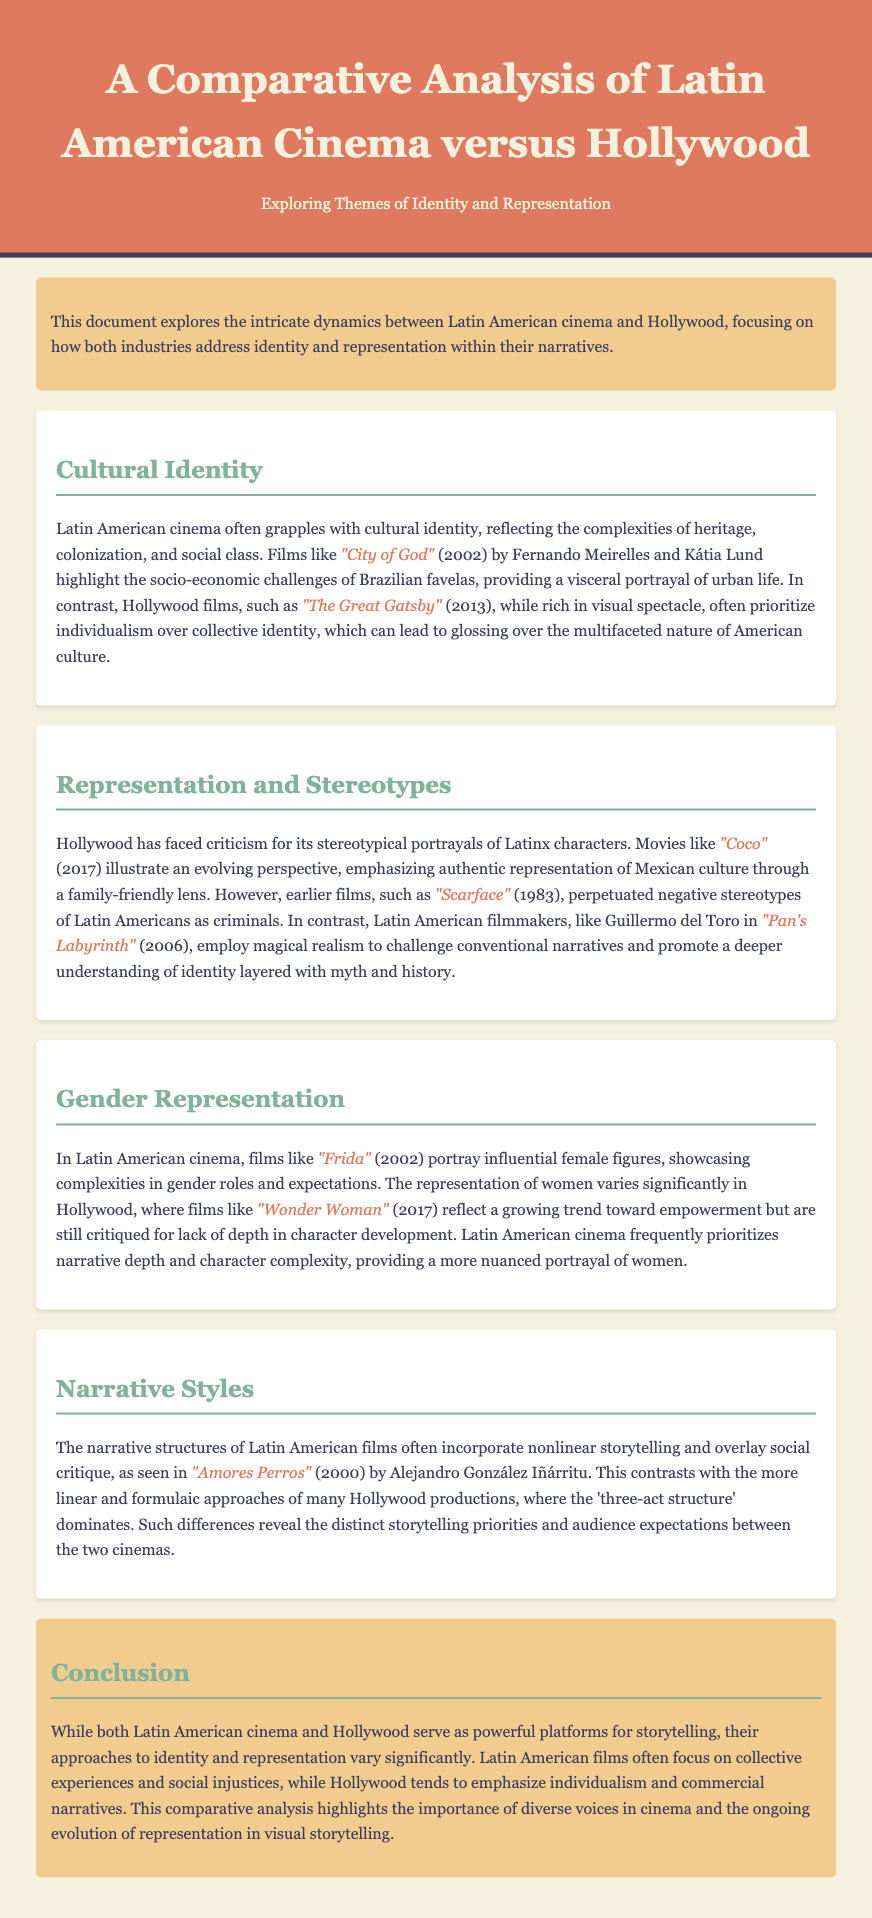What two films highlight socio-economic challenges in Brazilian favelas? The document mentions "City of God" by Fernando Meirelles and Kátia Lund to illustrate socio-economic challenges.
Answer: City of God Which film is cited as an example of Hollywood's stereotypical portrayal of Latinx characters? The document references "Scarface" as a film that perpetuated negative stereotypes of Latin Americans.
Answer: Scarface What narrative technique is noted as common in Latin American cinema? The text describes nonlinear storytelling as a common narrative structure in Latin American films.
Answer: Nonlinear storytelling Which film by Guillermo del Toro challenges conventional narratives? The document states that "Pan's Labyrinth" employs magical realism to promote a deeper understanding of identity.
Answer: Pan's Labyrinth What is a key theme of Latin American cinema mentioned in the document? The document identifies collective experiences and social injustices as key themes frequently explored in Latin American films.
Answer: Collective experiences Which film represents a growing trend toward women's empowerment in Hollywood? The document points to "Wonder Woman" as reflecting a trend in the portrayal of empowered female figures.
Answer: Wonder Woman What year was "Amores Perros" released? The document notes the release year of the film "Amores Perros" as 2000.
Answer: 2000 What is the color theme of the header in the document? The header is highlighted as having a background color of #e07a5f, which is described specifically in the styles.
Answer: #e07a5f What does the conclusion state about the storytelling approaches of Latin American cinema compared to Hollywood? The conclusion emphasizes the difference in focus on collective experiences by Latin American films versus the individualism emphasized in Hollywood productions.
Answer: Collective experiences vs individualism 